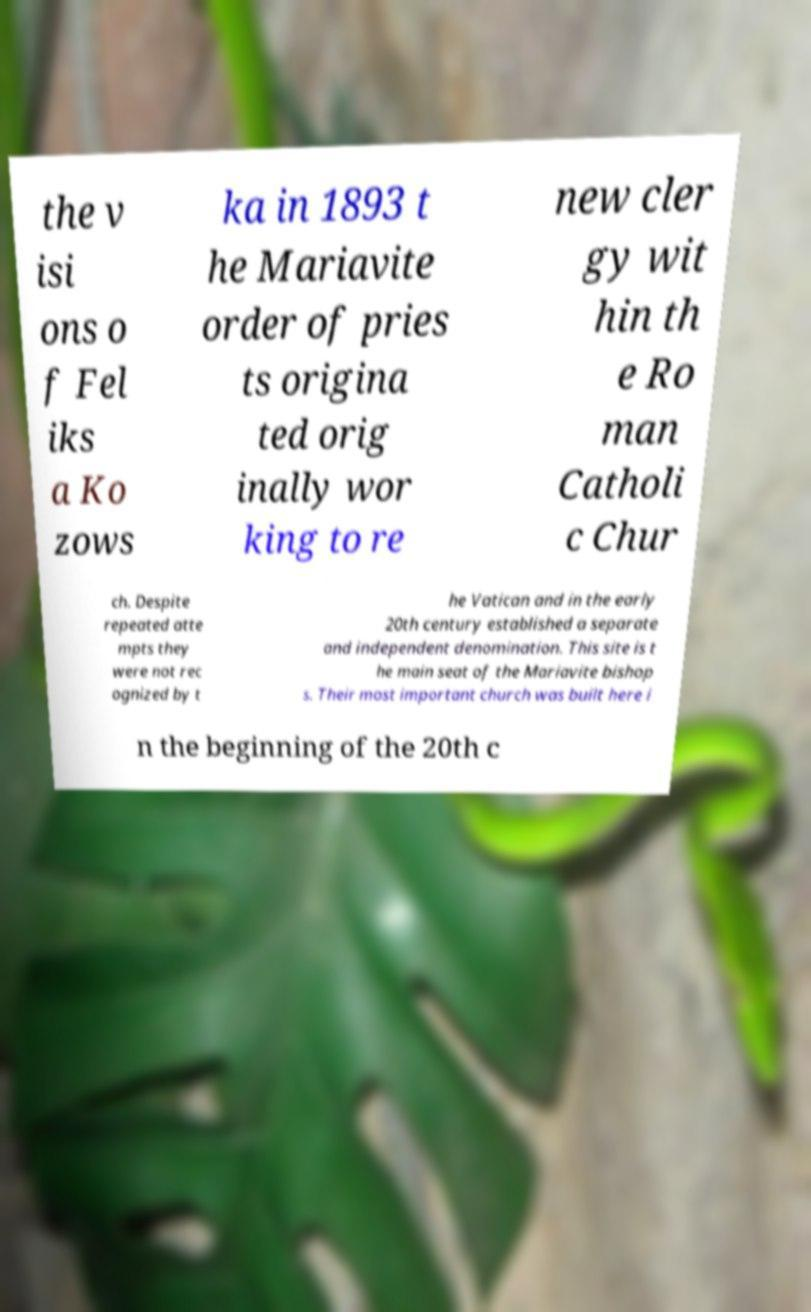I need the written content from this picture converted into text. Can you do that? the v isi ons o f Fel iks a Ko zows ka in 1893 t he Mariavite order of pries ts origina ted orig inally wor king to re new cler gy wit hin th e Ro man Catholi c Chur ch. Despite repeated atte mpts they were not rec ognized by t he Vatican and in the early 20th century established a separate and independent denomination. This site is t he main seat of the Mariavite bishop s. Their most important church was built here i n the beginning of the 20th c 